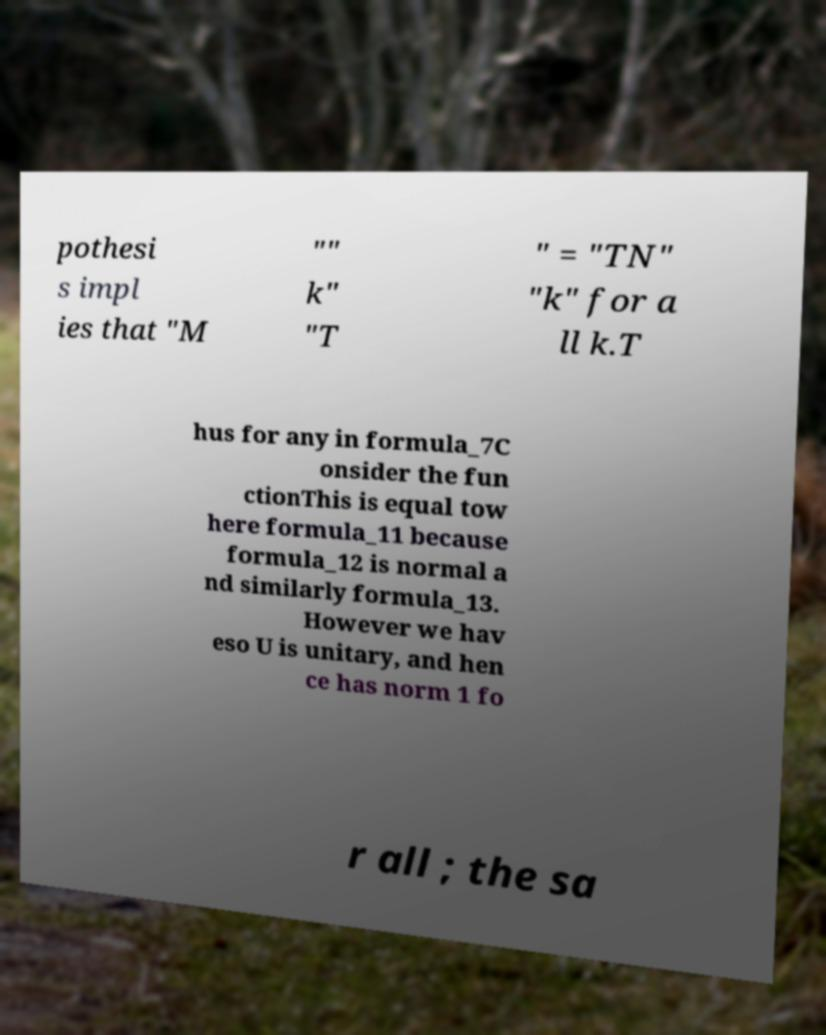What messages or text are displayed in this image? I need them in a readable, typed format. pothesi s impl ies that "M "" k" "T " = "TN" "k" for a ll k.T hus for any in formula_7C onsider the fun ctionThis is equal tow here formula_11 because formula_12 is normal a nd similarly formula_13. However we hav eso U is unitary, and hen ce has norm 1 fo r all ; the sa 